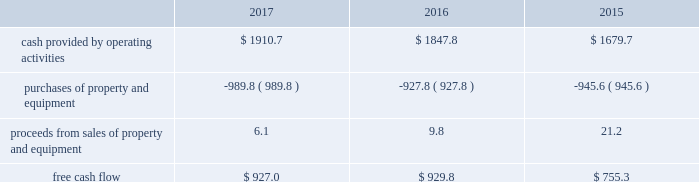Financial assurance we must provide financial assurance to governmental agencies and a variety of other entities under applicable environmental regulations relating to our landfill operations for capping , closure and post-closure costs , and related to our performance under certain collection , landfill and transfer station contracts .
We satisfy these financial assurance requirements by providing surety bonds , letters of credit , or insurance policies ( financial assurance instruments ) , or trust deposits , which are included in restricted cash and marketable securities and other assets in our consolidated balance sheets .
The amount of the financial assurance requirements for capping , closure and post-closure costs is determined by applicable state environmental regulations .
The financial assurance requirements for capping , closure and post-closure costs may be associated with a portion of the landfill or the entire landfill .
Generally , states require a third-party engineering specialist to determine the estimated capping , closure and post-closure costs that are used to determine the required amount of financial assurance for a landfill .
The amount of financial assurance required can , and generally will , differ from the obligation determined and recorded under u.s .
Gaap .
The amount of the financial assurance requirements related to contract performance varies by contract .
Additionally , we must provide financial assurance for our insurance program and collateral for certain performance obligations .
We do not expect a material increase in financial assurance requirements during 2018 , although the mix of financial assurance instruments may change .
These financial assurance instruments are issued in the normal course of business and are not considered indebtedness .
Because we currently have no liability for the financial assurance instruments , they are not reflected in our consolidated balance sheets ; however , we record capping , closure and post-closure liabilities and insurance liabilities as they are incurred .
Off-balance sheet arrangements we have no off-balance sheet debt or similar obligations , other than operating leases and financial assurances , which are not classified as debt .
We have no transactions or obligations with related parties that are not disclosed , consolidated into or reflected in our reported financial position or results of operations .
We have not guaranteed any third-party debt .
Free cash flow we define free cash flow , which is not a measure determined in accordance with u.s .
Gaap , as cash provided by operating activities less purchases of property and equipment , plus proceeds from sales of property and equipment , as presented in our consolidated statements of cash flows .
The table calculates our free cash flow for the years ended december 31 , 2017 , 2016 and 2015 ( in millions of dollars ) : .
For a discussion of the changes in the components of free cash flow , see our discussion regarding cash flows provided by operating activities and cash flows used in investing activities contained elsewhere in this management 2019s discussion and analysis of financial condition and results of operations. .
What is the average from the proceeds from sales of property and equipment from 2015 to 2017? 
Rationale: the average of the three years is equal to the the sum of the 3 years divide by three
Computations: ((((6.1 + 9.8) + 21.2) + 3) / 2)
Answer: 20.05. 